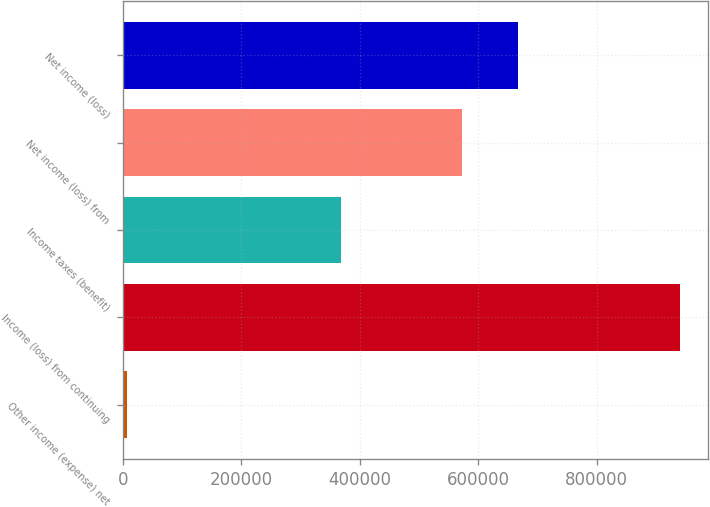<chart> <loc_0><loc_0><loc_500><loc_500><bar_chart><fcel>Other income (expense) net<fcel>Income (loss) from continuing<fcel>Income taxes (benefit)<fcel>Net income (loss) from<fcel>Net income (loss)<nl><fcel>6461<fcel>941090<fcel>367660<fcel>573430<fcel>666893<nl></chart> 